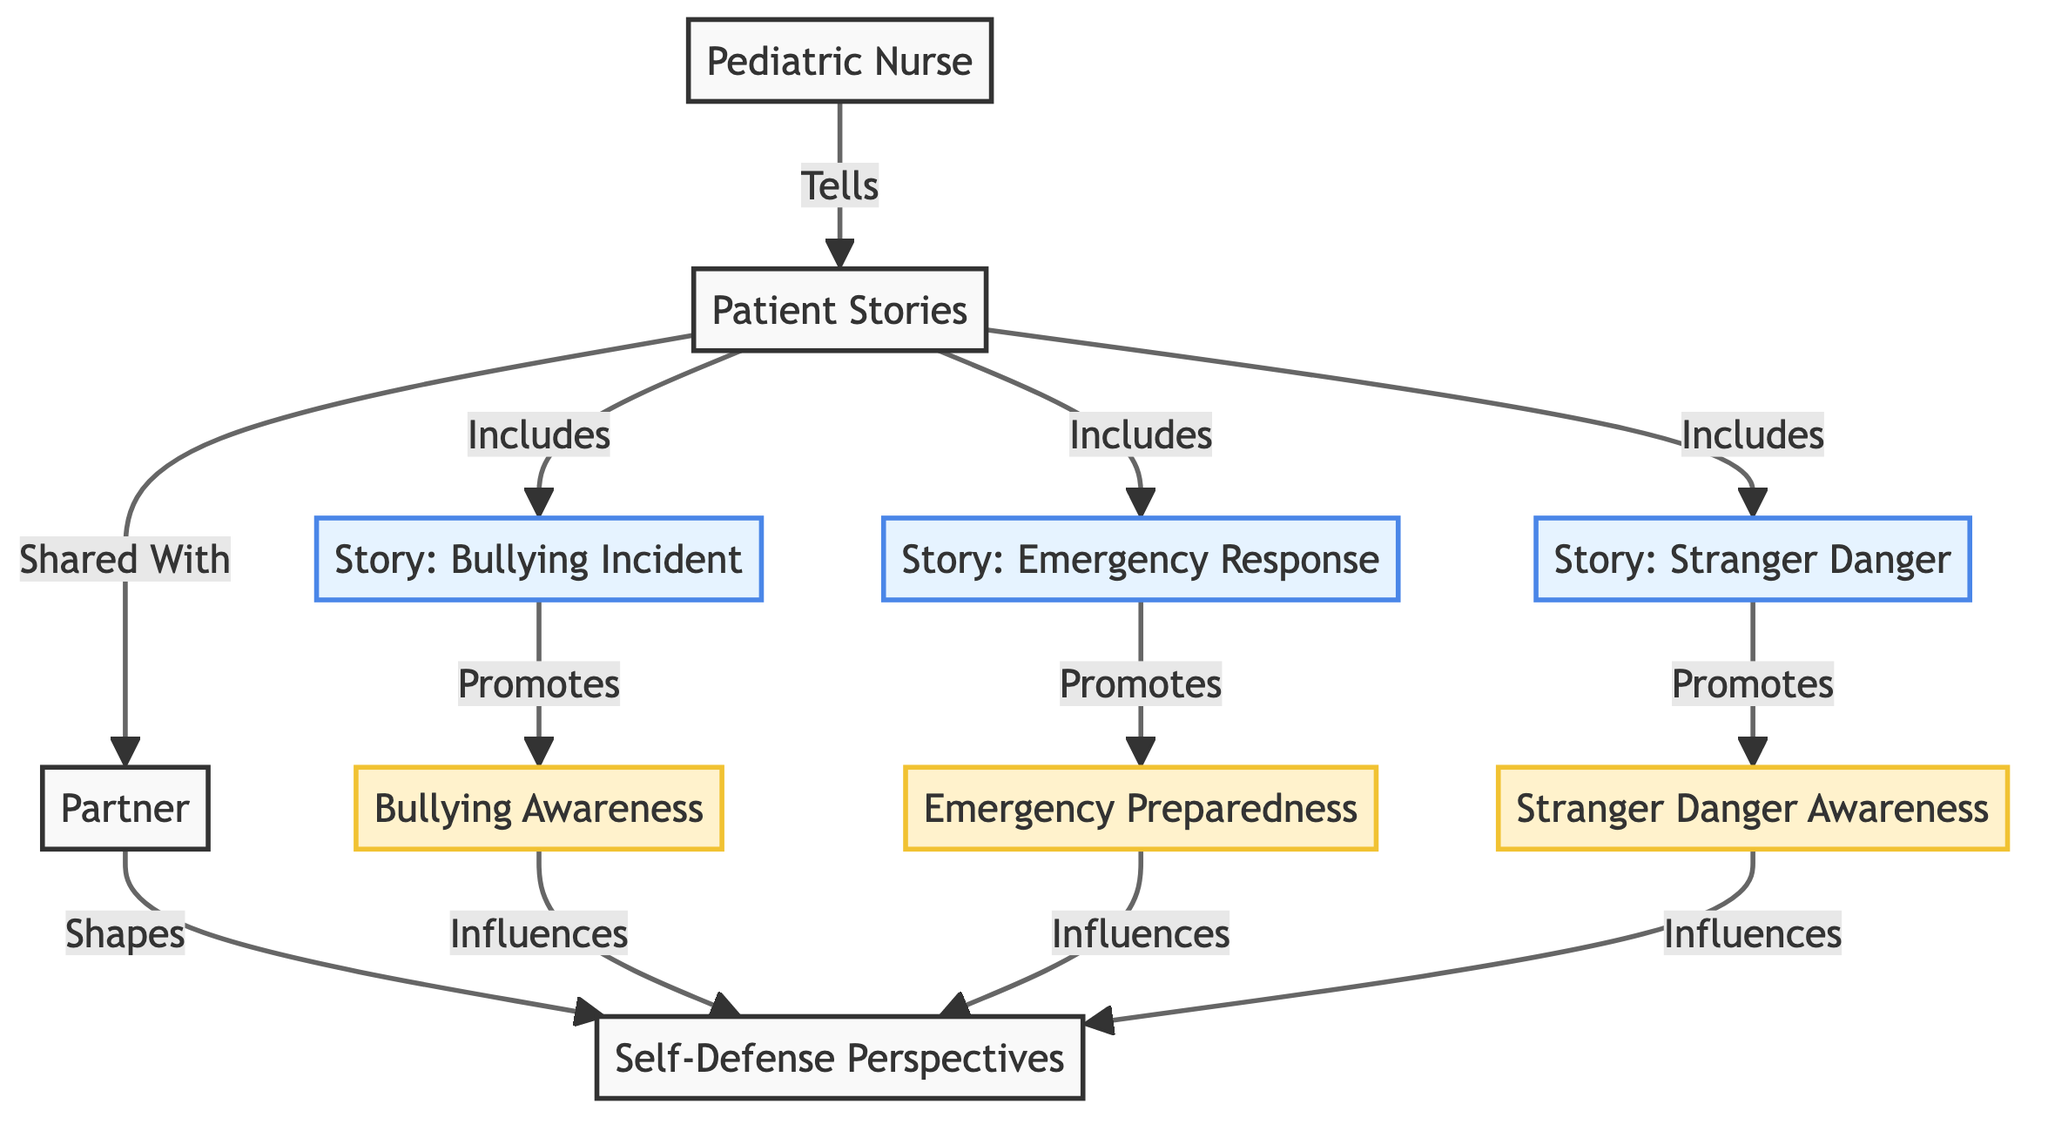What is the central node in the diagram? The central node connects multiple flows and represents the beginning of the story-sharing process, which is the "Patient Stories" node connected to the "Pediatric Nurse" and the "Partner."
Answer: Patient Stories How many stories are included in the patient stories? The diagram shows three stories flowing out from the "Patient Stories" node, represented by the nodes "Story: Bullying Incident," "Story: Emergency Response," and "Story: Stranger Danger."
Answer: 3 Which node does the pediatric nurse directly connect to? The pediatric nurse directly connects to the "Patient Stories" node, indicating that the nurse tells the stories.
Answer: Patient Stories What type of awareness does the "Story: Bullying Incident" promote? The edge from "Story: Bullying Incident" to "Bullying Awareness" specifies that this particular story promotes awareness about bullying.
Answer: Bullying Awareness What influence does "Emergency Preparedness" have in the diagram? "Emergency Preparedness" influences the "Self-Defense Perspectives," which means it plays a role in shaping the partner's views on self-defense based on what is learned from the stories.
Answer: Influences What relationship exists between patient stories and the partner node? The diagram indicates that patient stories are shared with the partner, establishing a direct informational connection between these two nodes.
Answer: Shared With Which story promotes stranger danger awareness? Looking at the connections, the "Story: Stranger Danger" specifically promotes the "Stranger Danger Awareness," highlighting the focus on this theme.
Answer: Story: Stranger Danger How many types of awareness are influenced by the stories? There are three types of awareness that are promoted: Bullying Awareness, Emergency Preparedness, and Stranger Danger Awareness, collectively influencing self-defense perspectives.
Answer: 3 What shapes the self-defense perspectives according to the diagram? The partner's direct connection to self-defense perspectives illustrates that both the shared stories and various types of awareness play a role in shaping these perspectives.
Answer: Shapes 